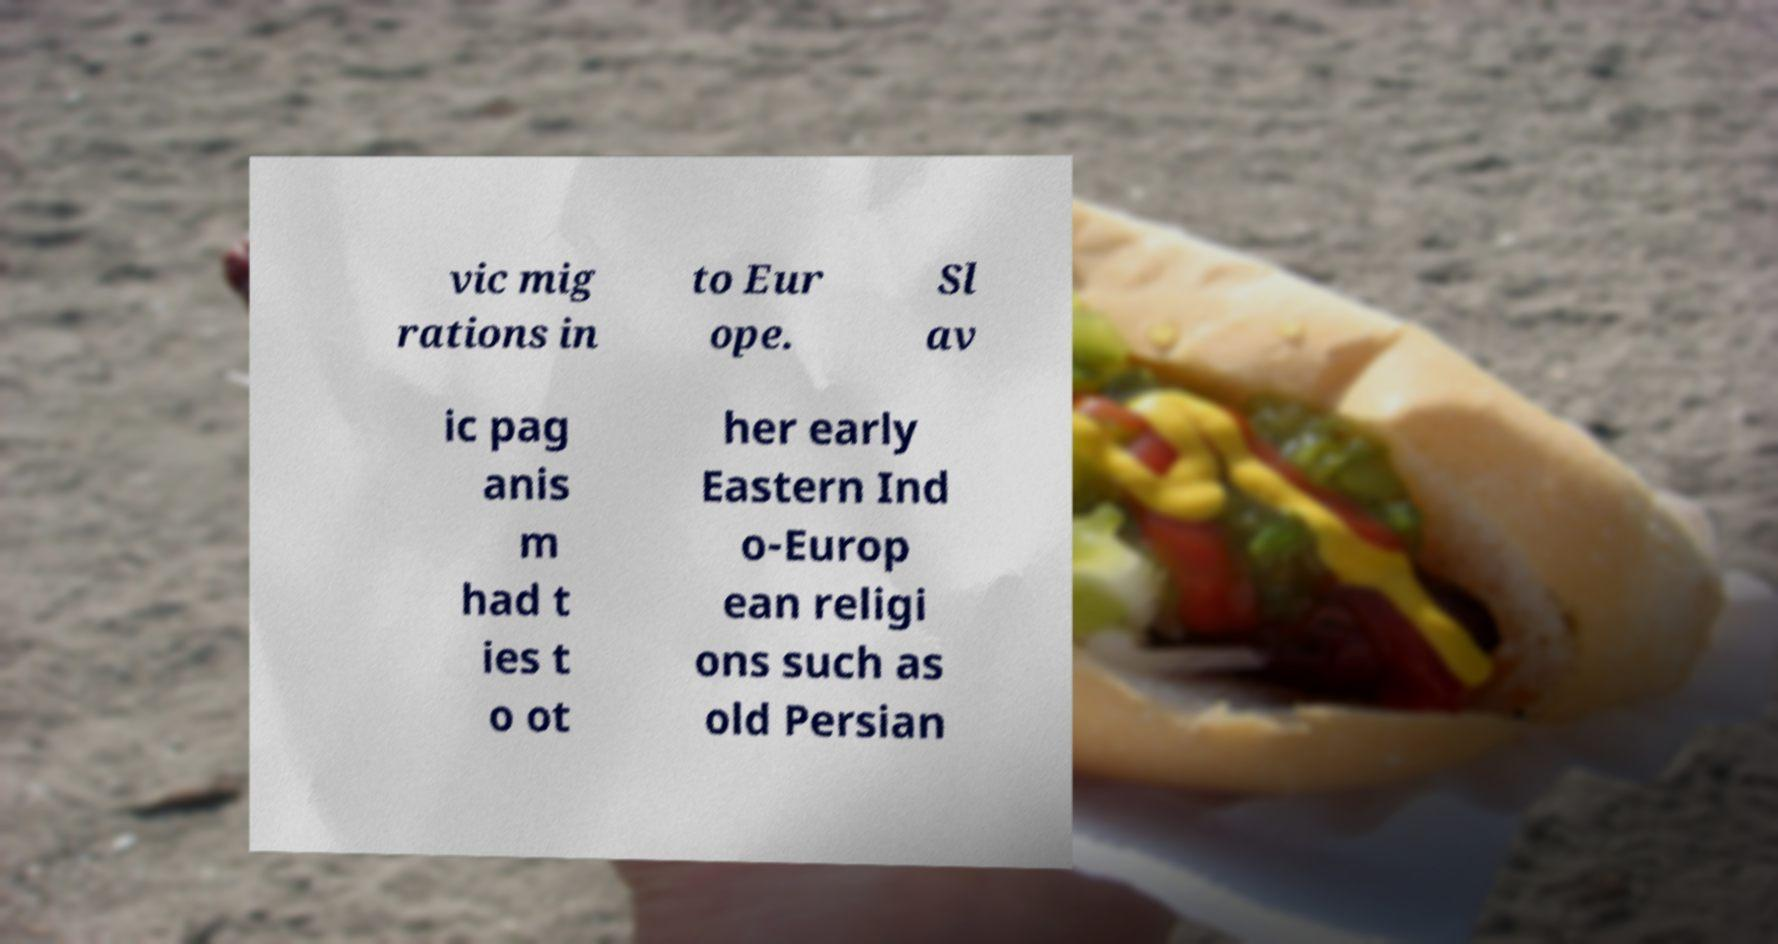Could you assist in decoding the text presented in this image and type it out clearly? vic mig rations in to Eur ope. Sl av ic pag anis m had t ies t o ot her early Eastern Ind o-Europ ean religi ons such as old Persian 